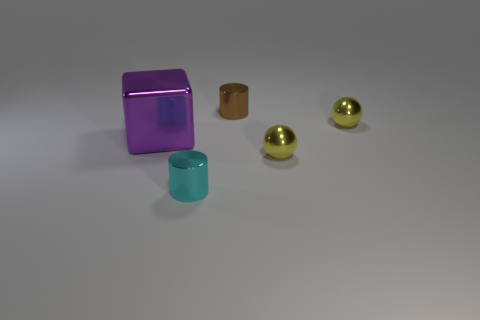Add 1 small cyan cylinders. How many objects exist? 6 Subtract all cylinders. How many objects are left? 3 Subtract all shiny balls. Subtract all big purple shiny objects. How many objects are left? 2 Add 4 big things. How many big things are left? 5 Add 1 large metallic blocks. How many large metallic blocks exist? 2 Subtract 0 gray balls. How many objects are left? 5 